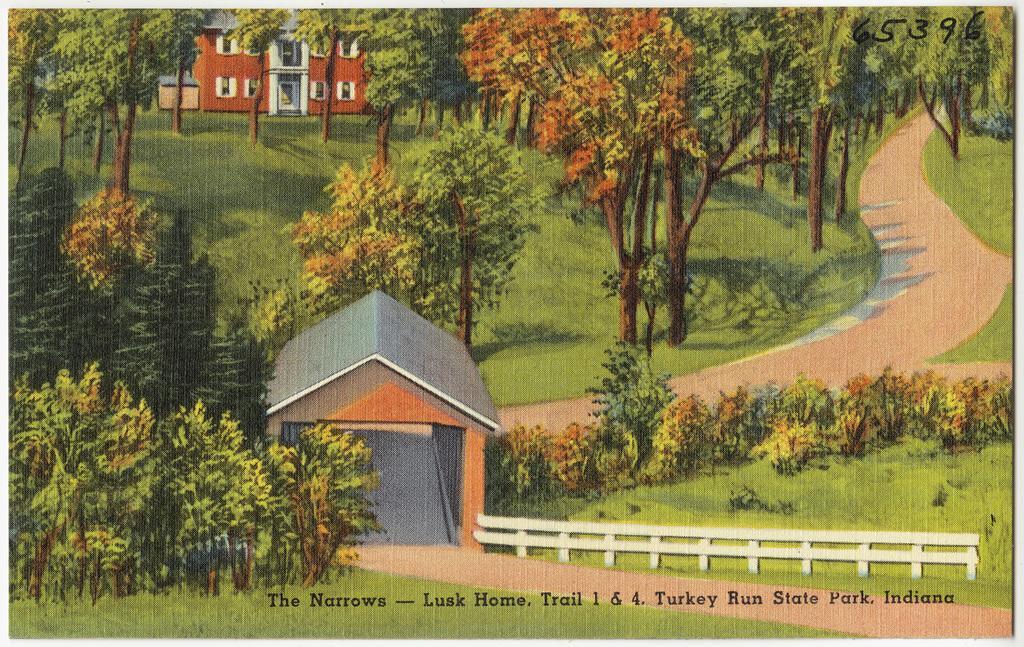In one or two sentences, can you explain what this image depicts? It is a poster. In this poster we can see buildings, trees, metal fence, road and grass on the surface. 